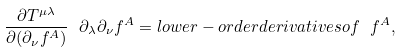<formula> <loc_0><loc_0><loc_500><loc_500>\frac { \partial T ^ { \mu \lambda } } { \partial ( \partial _ { \nu } f ^ { A } ) } \ \partial _ { \lambda } \partial _ { \nu } f ^ { A } = l o w e r - o r d e r d e r i v a t i v e s o f \ f ^ { A } ,</formula> 